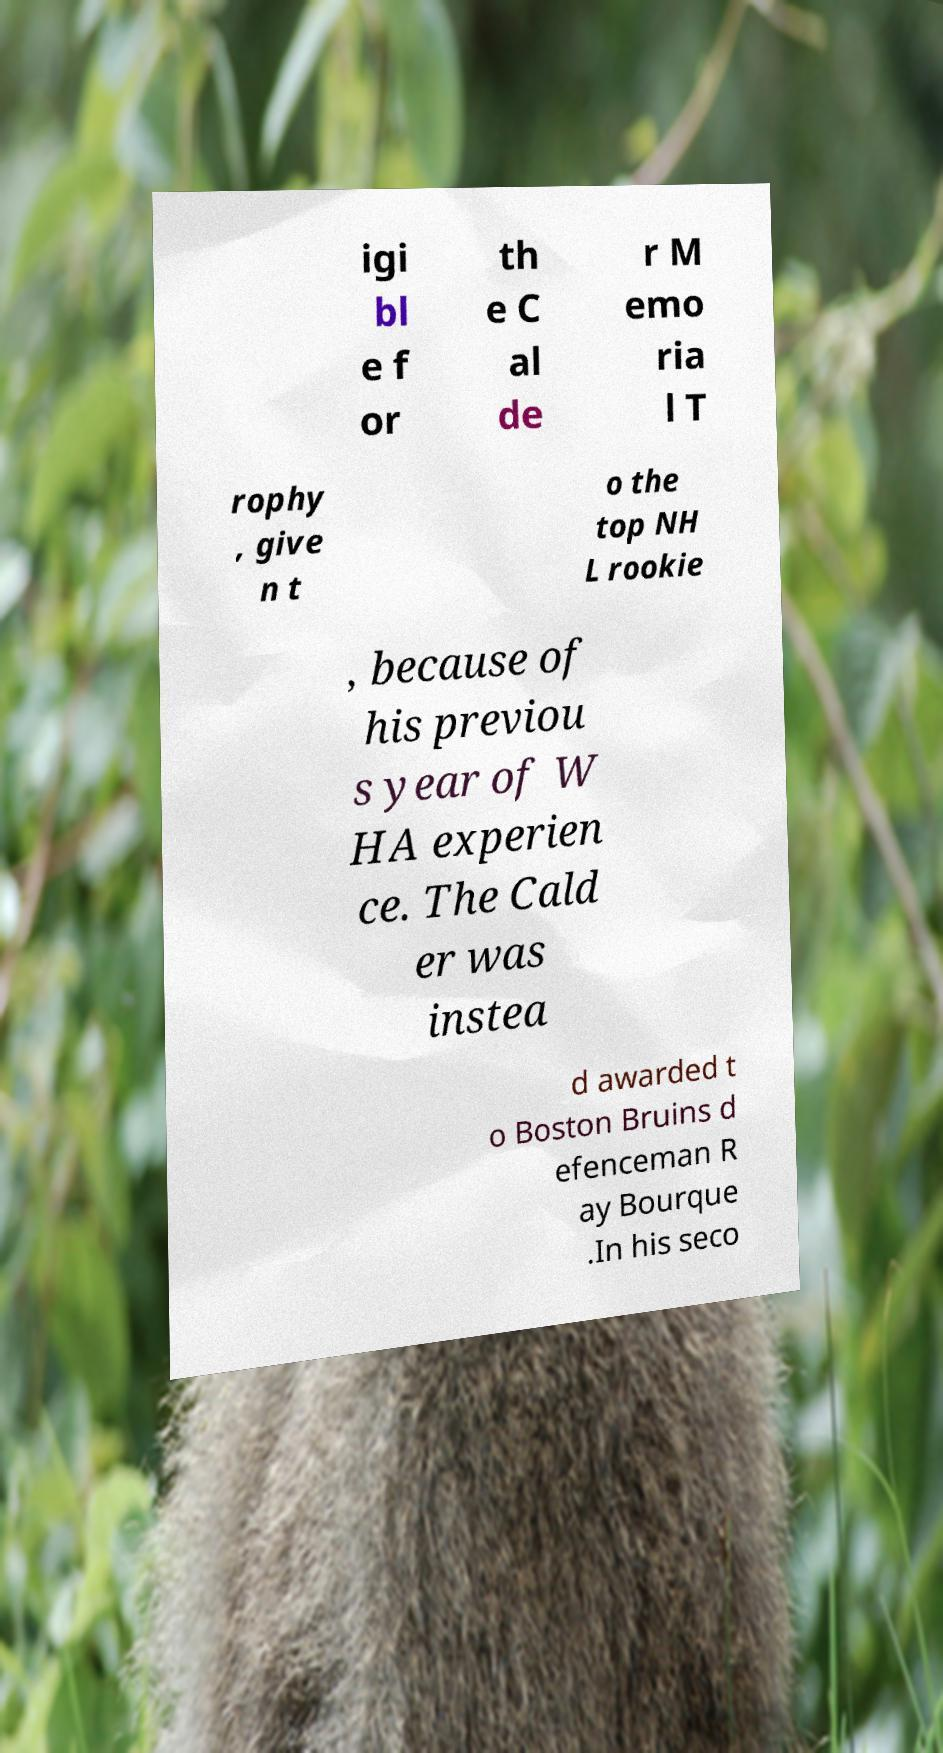There's text embedded in this image that I need extracted. Can you transcribe it verbatim? igi bl e f or th e C al de r M emo ria l T rophy , give n t o the top NH L rookie , because of his previou s year of W HA experien ce. The Cald er was instea d awarded t o Boston Bruins d efenceman R ay Bourque .In his seco 